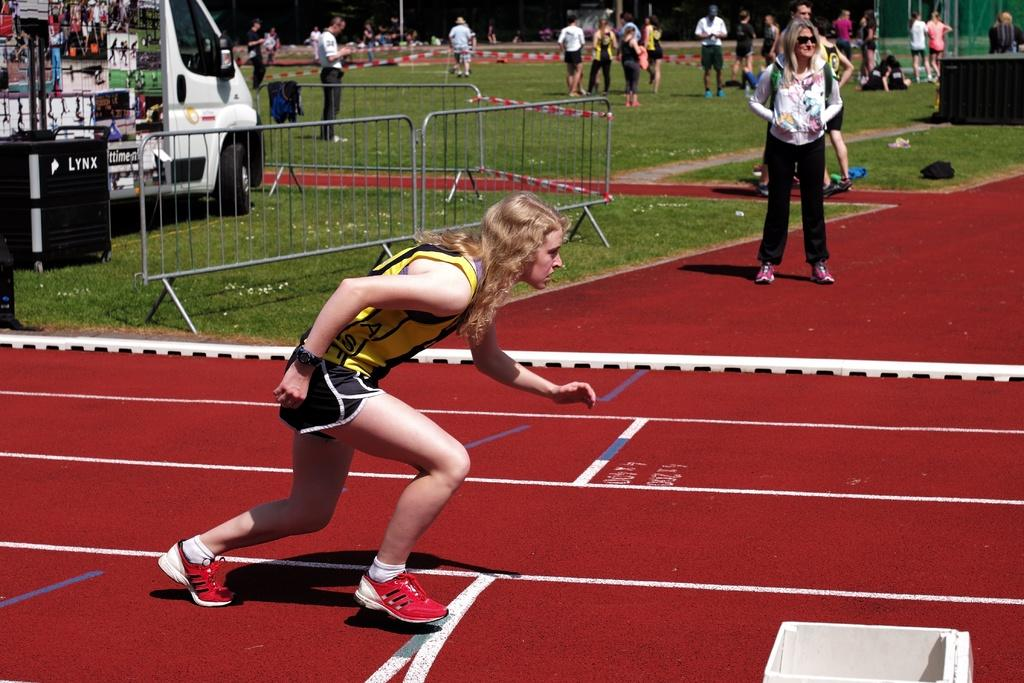<image>
Summarize the visual content of the image. Woman running in a rac with a speaker in the back that says LYNX. 